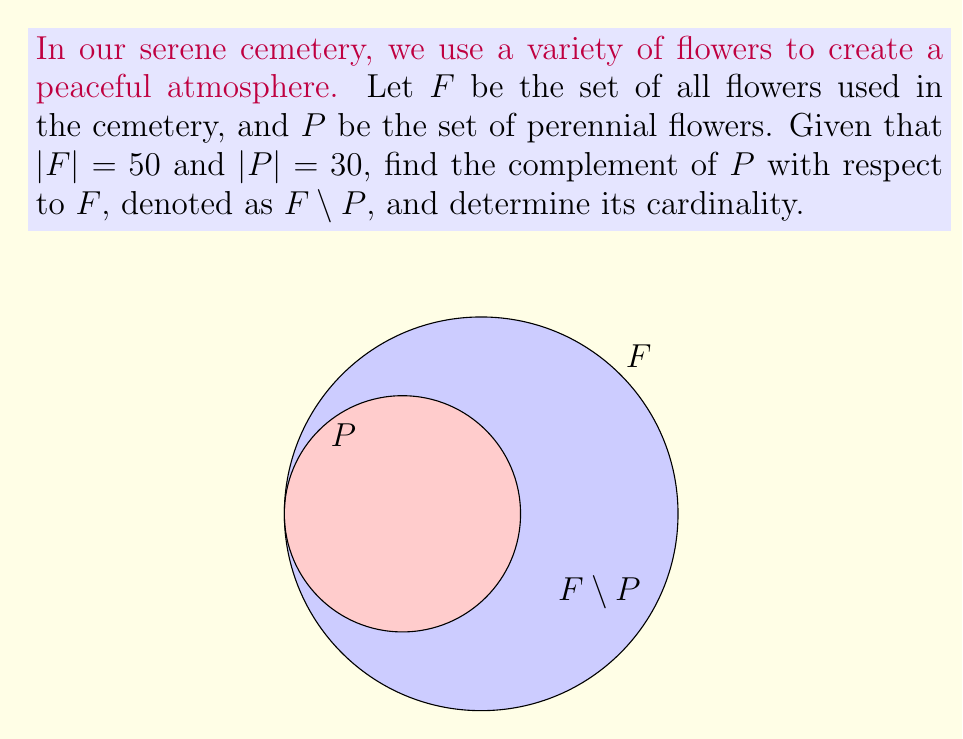Help me with this question. To solve this problem, let's follow these steps:

1) First, recall that the complement of set $P$ with respect to set $F$ is defined as:
   $F \setminus P = \{x \in F : x \notin P\}$

2) This means $F \setminus P$ contains all elements of $F$ that are not in $P$.

3) We're given that:
   $|F| = 50$ (total number of flowers used in the cemetery)
   $|P| = 30$ (number of perennial flowers)

4) The cardinality of $F \setminus P$ will be the number of flowers in $F$ that are not in $P$.

5) We can calculate this by subtracting the number of perennial flowers from the total number of flowers:
   $|F \setminus P| = |F| - |P| = 50 - 30 = 20$

6) Therefore, there are 20 flowers in the cemetery that are not perennials. These could be annual flowers or biennial flowers.

7) The set $F \setminus P$ represents these non-perennial flowers used in the cemetery.
Answer: $F \setminus P = \{x \in F : x \notin P\}$, $|F \setminus P| = 20$ 